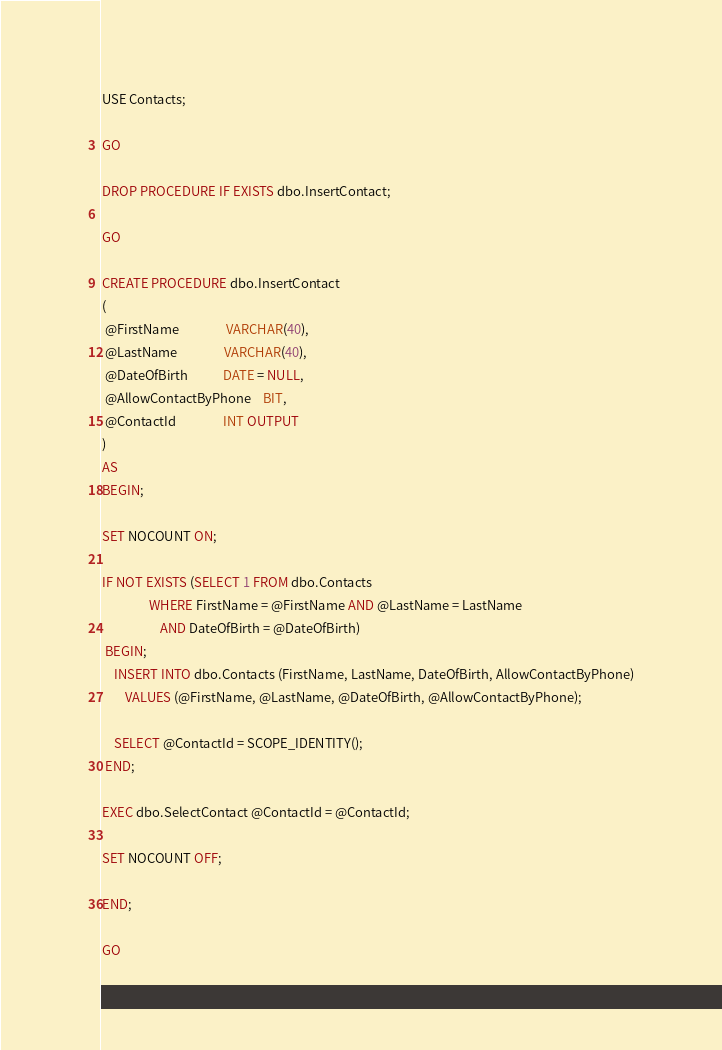<code> <loc_0><loc_0><loc_500><loc_500><_SQL_>USE Contacts;

GO

DROP PROCEDURE IF EXISTS dbo.InsertContact;

GO

CREATE PROCEDURE dbo.InsertContact
(
 @FirstName				VARCHAR(40),
 @LastName				VARCHAR(40),
 @DateOfBirth			DATE = NULL,
 @AllowContactByPhone	BIT,
 @ContactId				INT OUTPUT
)
AS
BEGIN;

SET NOCOUNT ON;

IF NOT EXISTS (SELECT 1 FROM dbo.Contacts
				WHERE FirstName = @FirstName AND @LastName = LastName
					AND DateOfBirth = @DateOfBirth)
 BEGIN;
	INSERT INTO dbo.Contacts (FirstName, LastName, DateOfBirth, AllowContactByPhone)
		VALUES (@FirstName, @LastName, @DateOfBirth, @AllowContactByPhone);

	SELECT @ContactId = SCOPE_IDENTITY();
 END;

EXEC dbo.SelectContact @ContactId = @ContactId;

SET NOCOUNT OFF;

END;

GO</code> 